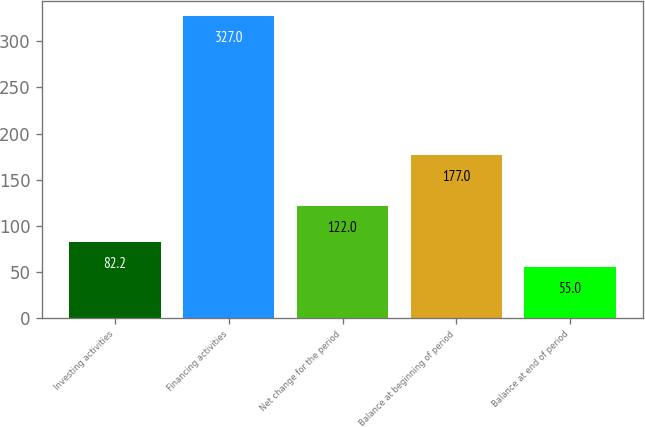Convert chart to OTSL. <chart><loc_0><loc_0><loc_500><loc_500><bar_chart><fcel>Investing activities<fcel>Financing activities<fcel>Net change for the period<fcel>Balance at beginning of period<fcel>Balance at end of period<nl><fcel>82.2<fcel>327<fcel>122<fcel>177<fcel>55<nl></chart> 